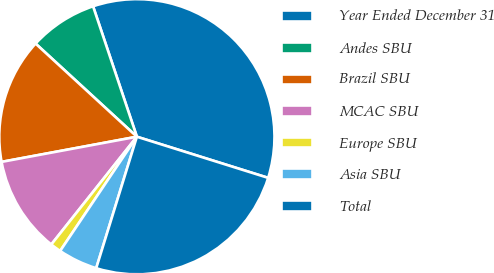Convert chart to OTSL. <chart><loc_0><loc_0><loc_500><loc_500><pie_chart><fcel>Year Ended December 31<fcel>Andes SBU<fcel>Brazil SBU<fcel>MCAC SBU<fcel>Europe SBU<fcel>Asia SBU<fcel>Total<nl><fcel>34.99%<fcel>8.01%<fcel>14.76%<fcel>11.39%<fcel>1.27%<fcel>4.64%<fcel>24.94%<nl></chart> 